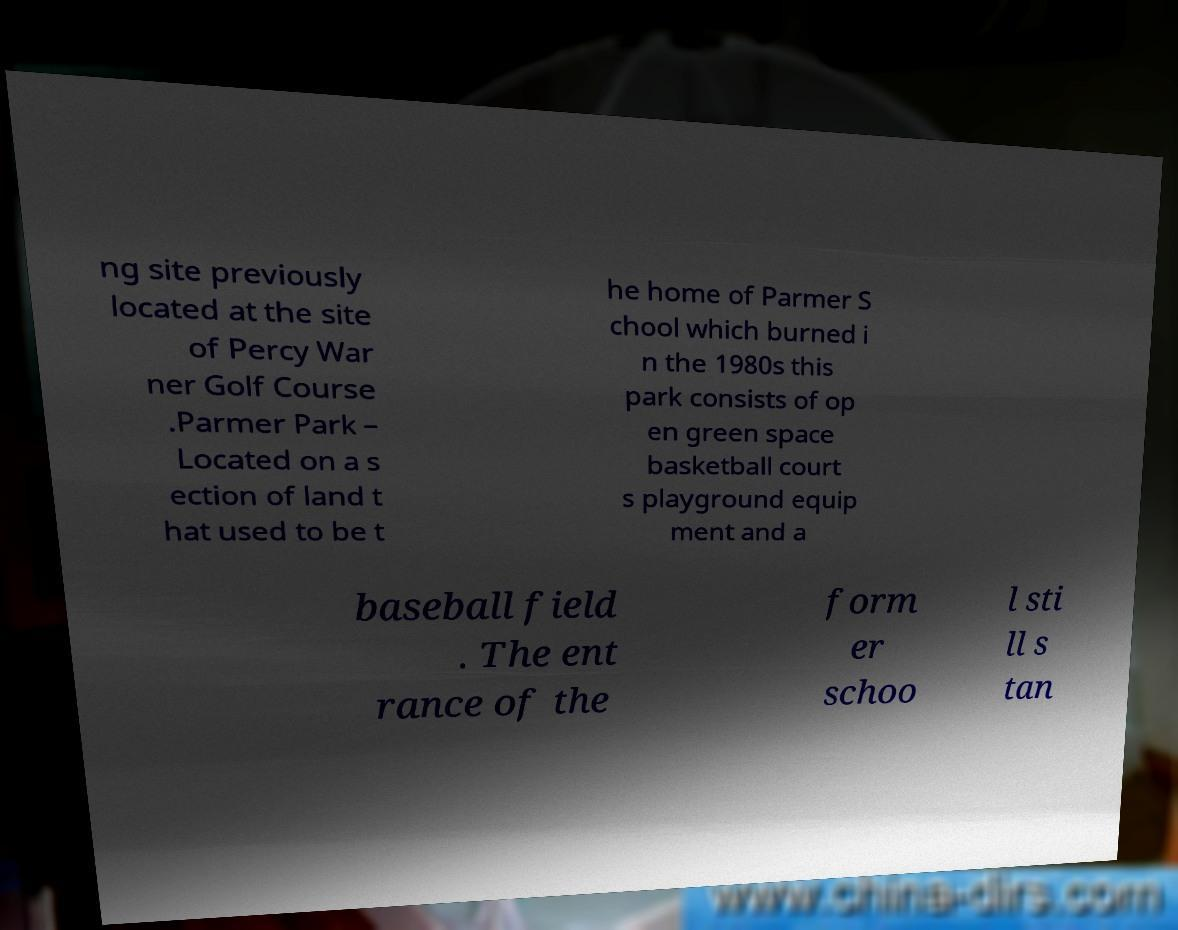For documentation purposes, I need the text within this image transcribed. Could you provide that? ng site previously located at the site of Percy War ner Golf Course .Parmer Park – Located on a s ection of land t hat used to be t he home of Parmer S chool which burned i n the 1980s this park consists of op en green space basketball court s playground equip ment and a baseball field . The ent rance of the form er schoo l sti ll s tan 